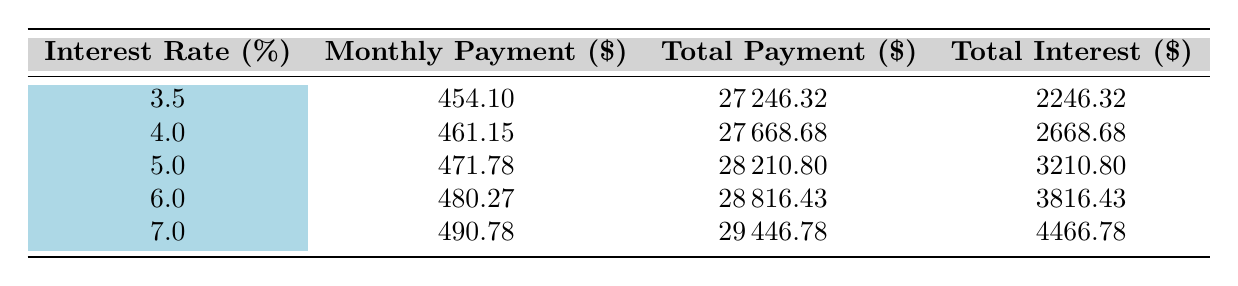What is the monthly payment for a 5.0% interest rate? The monthly payment for a 5.0% interest rate is listed in the table as 471.78.
Answer: 471.78 How much is the total payment for a loan at a 4.0% interest rate? The total payment for a 4.0% interest rate is provided in the table as 27668.68.
Answer: 27668.68 What is the difference in total interest between the loans with 3.5% and 7.0% interest rates? The total interest for 3.5% is 2246.32 and for 7.0% is 4466.78. The difference is 4466.78 - 2246.32 = 2220.46.
Answer: 2220.46 Is the total payment for the loan at a 6.0% interest rate higher than for a 5.0% interest rate? Yes, the total payment for 6.0% is 28816.43, which is higher than the total payment of 28210.80 for 5.0%.
Answer: Yes What is the average monthly payment for all listed interest rates? The monthly payments for the listed rates are 454.10, 461.15, 471.78, 480.27, and 490.78. The total is 454.10 + 461.15 + 471.78 + 480.27 + 490.78 = 2358.08. The average is 2358.08 divided by 5, which equals 471.616.
Answer: 471.62 What is the total interest amount for the loan at a 6.0% interest rate? The total interest for the loan at a 6.0% interest rate is shown in the table as 3816.43.
Answer: 3816.43 Which interest rate results in the lowest total interest paid? The lowest total interest paid is for the 3.5% interest rate, which is 2246.32, as shown in the table.
Answer: 2246.32 If someone chooses the 7.0% interest rate, what would be their total payments throughout the loan term? According to the table, the total payment for the 7.0% interest rate is 29446.78, which would be the total paid throughout the loan term.
Answer: 29446.78 